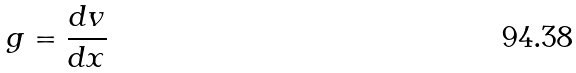Convert formula to latex. <formula><loc_0><loc_0><loc_500><loc_500>g = \frac { d v } { d x }</formula> 